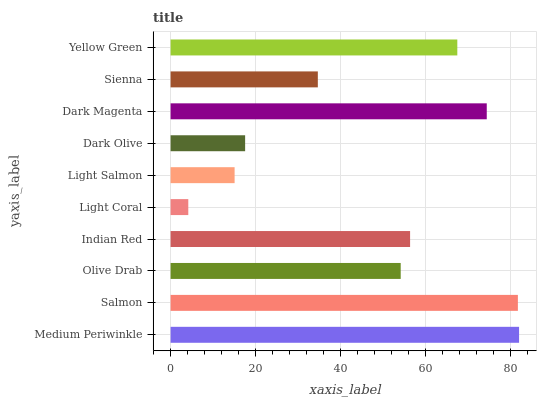Is Light Coral the minimum?
Answer yes or no. Yes. Is Medium Periwinkle the maximum?
Answer yes or no. Yes. Is Salmon the minimum?
Answer yes or no. No. Is Salmon the maximum?
Answer yes or no. No. Is Medium Periwinkle greater than Salmon?
Answer yes or no. Yes. Is Salmon less than Medium Periwinkle?
Answer yes or no. Yes. Is Salmon greater than Medium Periwinkle?
Answer yes or no. No. Is Medium Periwinkle less than Salmon?
Answer yes or no. No. Is Indian Red the high median?
Answer yes or no. Yes. Is Olive Drab the low median?
Answer yes or no. Yes. Is Medium Periwinkle the high median?
Answer yes or no. No. Is Light Coral the low median?
Answer yes or no. No. 